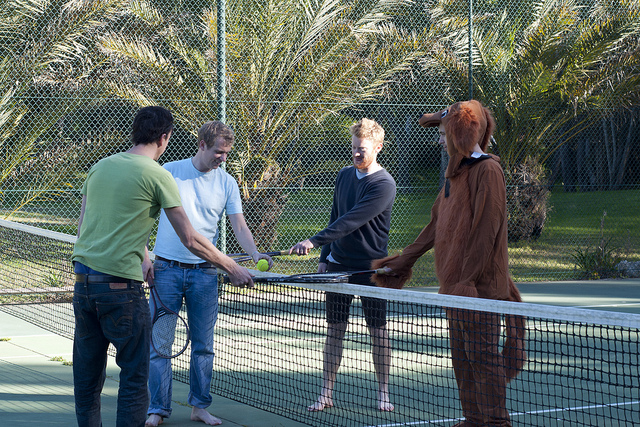Imagine a fantasy world where these characters are part of a magical sports league. Describe their roles. In a magical sports league, these characters could be enchanted athletes with unique abilities. The man in the green shirt could be 'The Earth Shaker,' using his connection with the ground to alter the court's terrain for strategic advantage. The person in the white t-shirt, 'The Lightbringer,' can manipulate light, making the tennis ball flare up or disappear momentarily, confusing opponents. The individual in the dark shirt, known as 'The Wind Whisperer,' commands gusts to steer the ball mid-air, making it hard to predict its path. Lastly, the one in the dog costume, 'The Beast Master,' has a magical aura that can summon animal spirits to assist or protect the team during matches. Together, they form an unbeatable team known as 'The Elementals,' reigning champions in the fantastical realm of sports. 